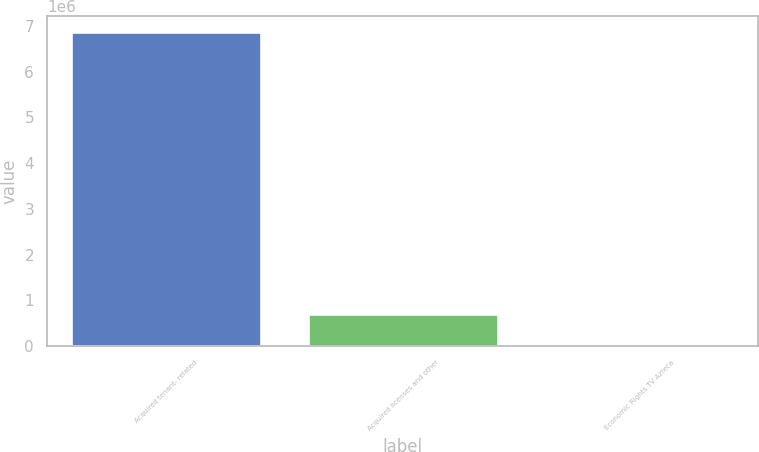Convert chart to OTSL. <chart><loc_0><loc_0><loc_500><loc_500><bar_chart><fcel>Acquired tenant- related<fcel>Acquired licenses and other<fcel>Economic Rights TV Azteca<nl><fcel>6.8767e+06<fcel>697102<fcel>10480<nl></chart> 